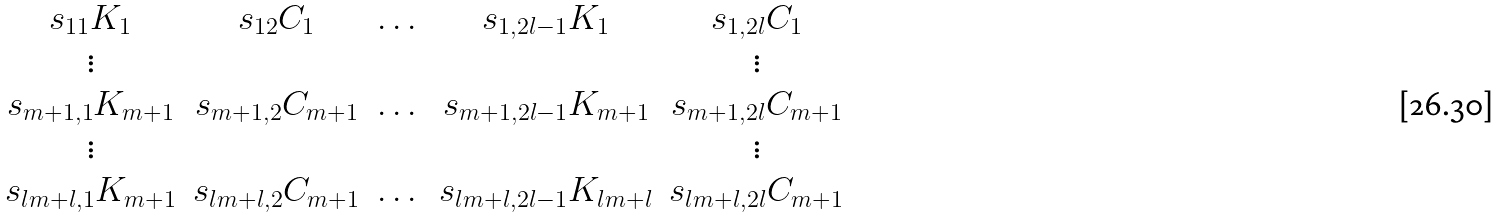Convert formula to latex. <formula><loc_0><loc_0><loc_500><loc_500>\begin{matrix} s _ { 1 1 } K _ { 1 } & s _ { 1 2 } C _ { 1 } & \dots & s _ { 1 , 2 l - 1 } K _ { 1 } & s _ { 1 , 2 l } C _ { 1 } \\ \vdots & & & & \vdots \\ s _ { m + 1 , 1 } K _ { m + 1 } & s _ { m + 1 , 2 } C _ { m + 1 } & \dots & s _ { m + 1 , 2 l - 1 } K _ { m + 1 } & s _ { m + 1 , 2 l } C _ { m + 1 } \\ \vdots & & & & \vdots \\ s _ { l m + l , 1 } K _ { m + 1 } & s _ { l m + l , 2 } C _ { m + 1 } & \dots & s _ { l m + l , 2 l - 1 } K _ { l m + l } & s _ { l m + l , 2 l } C _ { m + 1 } \\ \end{matrix}</formula> 